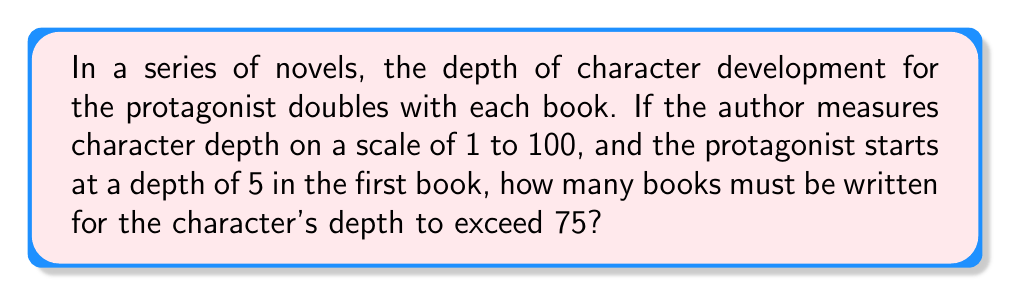Help me with this question. Let's approach this step-by-step:

1) We start with a depth of 5 in the first book.
2) The depth doubles with each book, so we can represent this as an exponential function:
   $f(n) = 5 \cdot 2^{n-1}$, where $n$ is the book number.

3) We need to find $n$ where $f(n) > 75$:
   $5 \cdot 2^{n-1} > 75$

4) Divide both sides by 5:
   $2^{n-1} > 15$

5) Take the logarithm (base 2) of both sides:
   $\log_2(2^{n-1}) > \log_2(15)$
   $n-1 > \log_2(15)$

6) Solve for $n$:
   $n > \log_2(15) + 1$

7) Calculate:
   $\log_2(15) \approx 3.91$
   $n > 3.91 + 1 = 4.91$

8) Since $n$ must be a whole number (we can't have a fraction of a book), we round up to the next integer.

Therefore, the author must write 5 books for the character's depth to exceed 75.
Answer: 5 books 